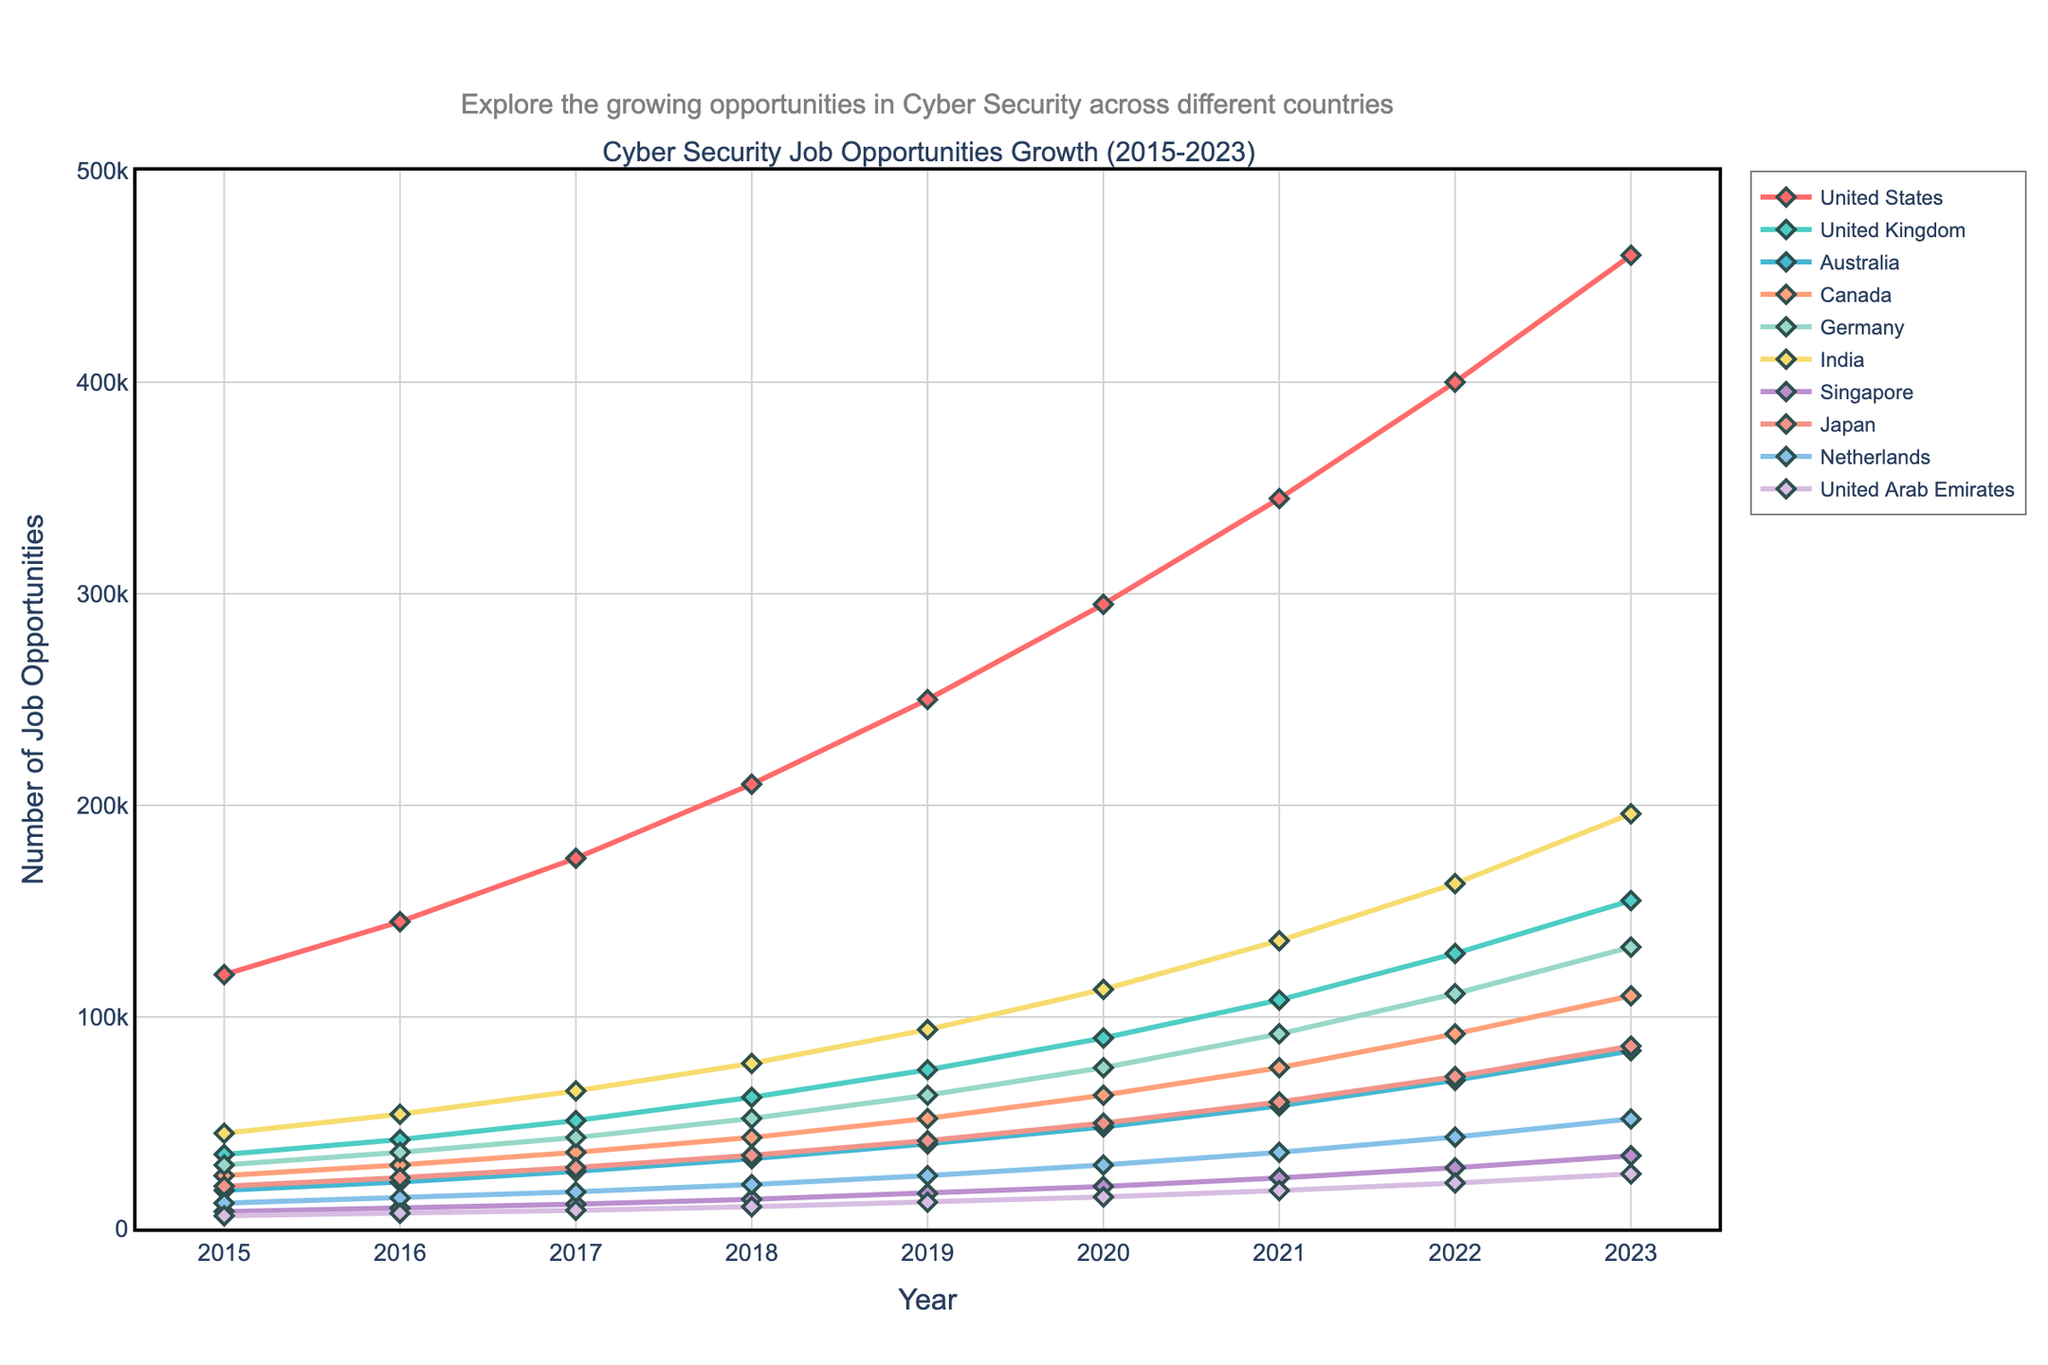Which country had the highest number of job opportunities in 2023? Referring to the figure, the line for the United States is the highest in 2023, reaching around 460,000. This indicates that the United States had the highest number of job opportunities in 2023.
Answer: United States How many job opportunities were created in Germany from 2015 to 2023? To find the total number of job opportunities created in Germany from 2015 to 2023, we need to subtract the number in 2015 from that in 2023: 133,000 - 30,000 = 103,000.
Answer: 103,000 Compare the growth in job opportunities between India and Australia from 2015 to 2023. Which country experienced higher growth? The growth in India: 196,000 (2023) - 45,000 (2015) = 151,000. The growth in Australia: 84,000 (2023) - 18,000 (2015) = 66,000. India experienced higher growth as 151,000 is greater than 66,000.
Answer: India What’s the average number of job opportunities in the United Kingdom over the years displayed? Sum the job opportunities from 2015 to 2023 in the United Kingdom and divide by the number of years: (35,000 + 42,000 + 51,000 + 62,000 + 75,000 + 90,000 + 108,000 + 130,000 + 155,000) / 9 = 83,556.
Answer: 83,556 Which country showed the least increase in job opportunities from 2015 to 2023? To determine the least increase, calculate the difference for each country and compare them: Singapore had the least increase: 34,400 (2023) - 8,000 (2015) = 26,400.
Answer: Singapore What is the difference in the number of job opportunities between Japan and the Netherlands in 2022? The number of opportunities in Japan (2022): 71,800 and in the Netherlands (2022): 43,200. The difference: 71,800 - 43,200 = 28,600.
Answer: 28,600 Which year marked the first time India surpassed 100,000 job opportunities? Based on the data visualized, India had 113,000 job opportunities in 2020, which was the first instance of surpassing 100,000.
Answer: 2020 Did Canada have more than 50,000 job opportunities in 2019? In 2019, Canada had 52,000 job opportunities as per the data on the figure, which is more than 50,000.
Answer: Yes How many countries had at least 100,000 job opportunities in 2023? Referring to the figure, the countries that had at least 100,000 job opportunities in 2023 are the United States, the United Kingdom, Germany, India, and Canada. That's 5 countries.
Answer: 5 By how much did the job opportunities in the United Arab Emirates increase from 2020 to 2022? By looking at the figure, job opportunities in the UAE were 14,900 in 2020 and increased to 21,500 by 2022. The increase is: 21,500 - 14,900 = 6,600.
Answer: 6,600 